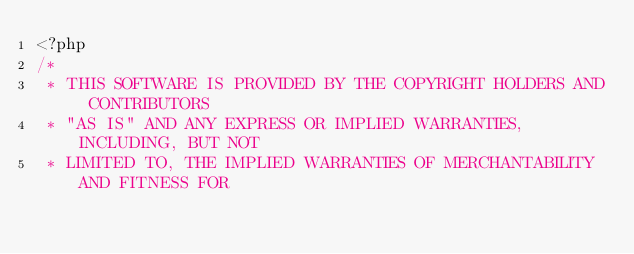<code> <loc_0><loc_0><loc_500><loc_500><_PHP_><?php
/*
 * THIS SOFTWARE IS PROVIDED BY THE COPYRIGHT HOLDERS AND CONTRIBUTORS
 * "AS IS" AND ANY EXPRESS OR IMPLIED WARRANTIES, INCLUDING, BUT NOT
 * LIMITED TO, THE IMPLIED WARRANTIES OF MERCHANTABILITY AND FITNESS FOR</code> 